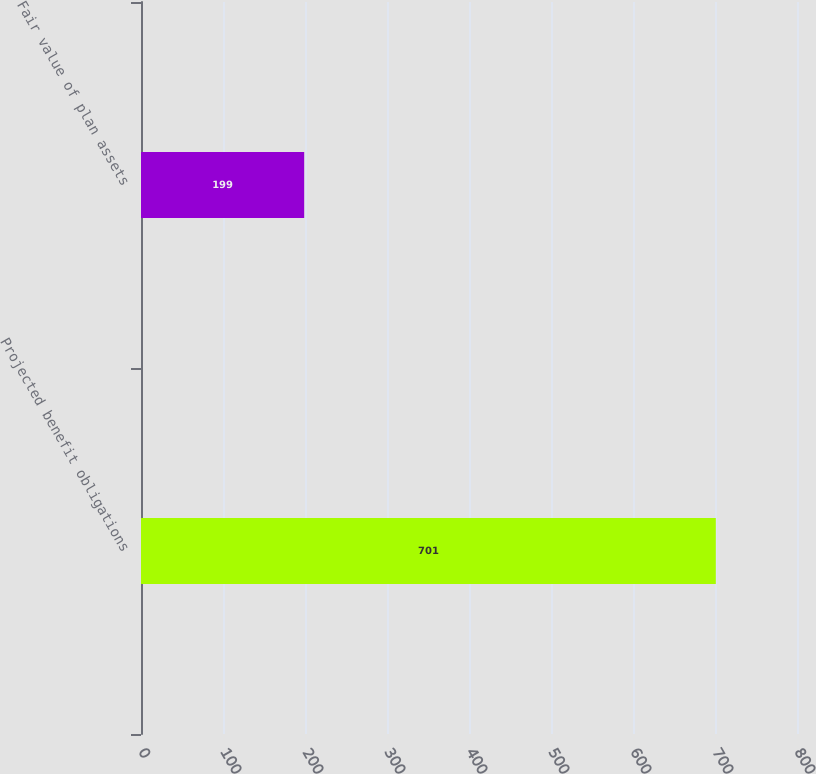Convert chart. <chart><loc_0><loc_0><loc_500><loc_500><bar_chart><fcel>Projected benefit obligations<fcel>Fair value of plan assets<nl><fcel>701<fcel>199<nl></chart> 